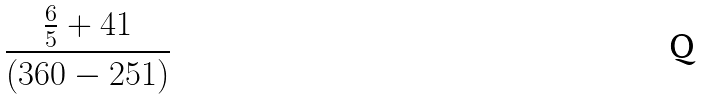<formula> <loc_0><loc_0><loc_500><loc_500>\frac { \frac { 6 } { 5 } + 4 1 } { ( 3 6 0 - 2 5 1 ) }</formula> 